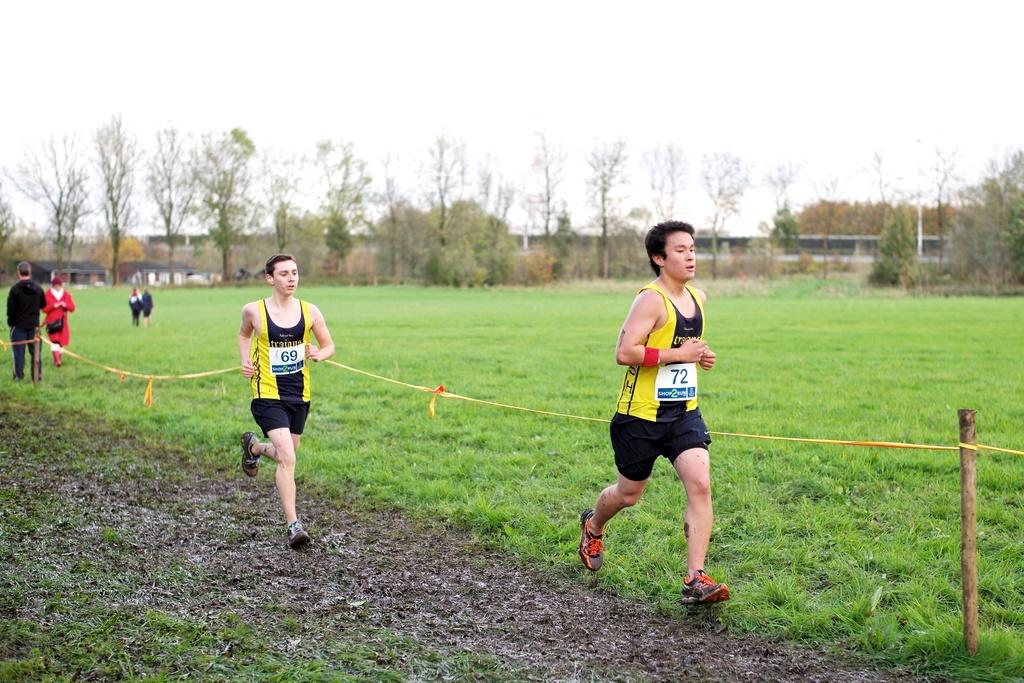Which runner number is leading?
Provide a succinct answer. 72. What number is in decond place?
Give a very brief answer. 69. 